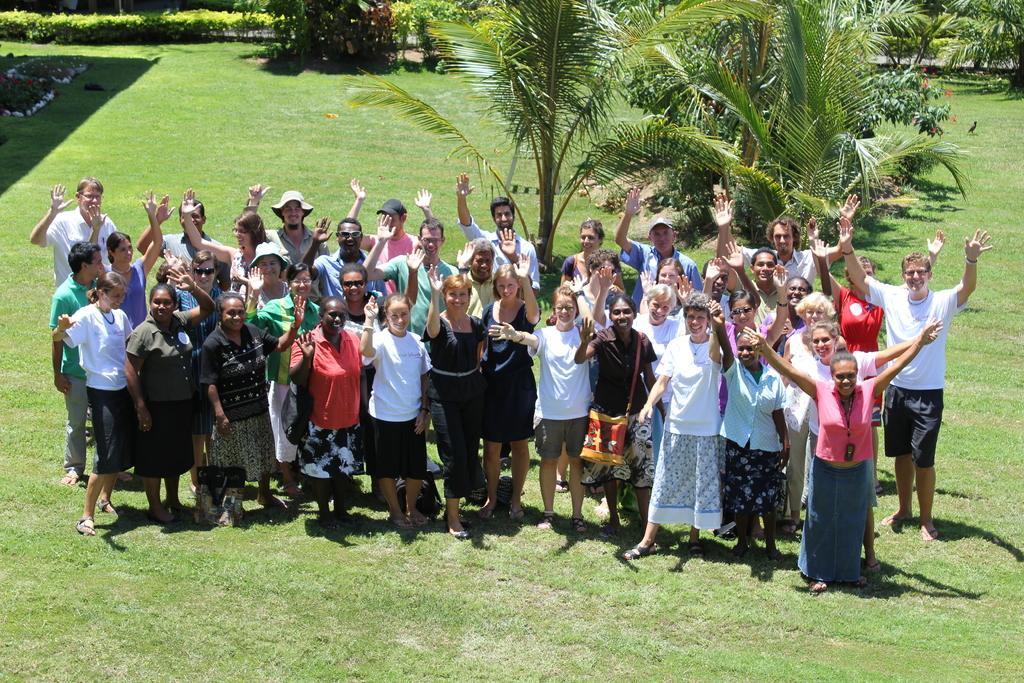Please provide a concise description of this image. In this image in front there are a group of people having a smile on their faces. On the right side of the image there is a bird. At the bottom of the image there is grass on the surface. In the background of the image there are plants, trees. 